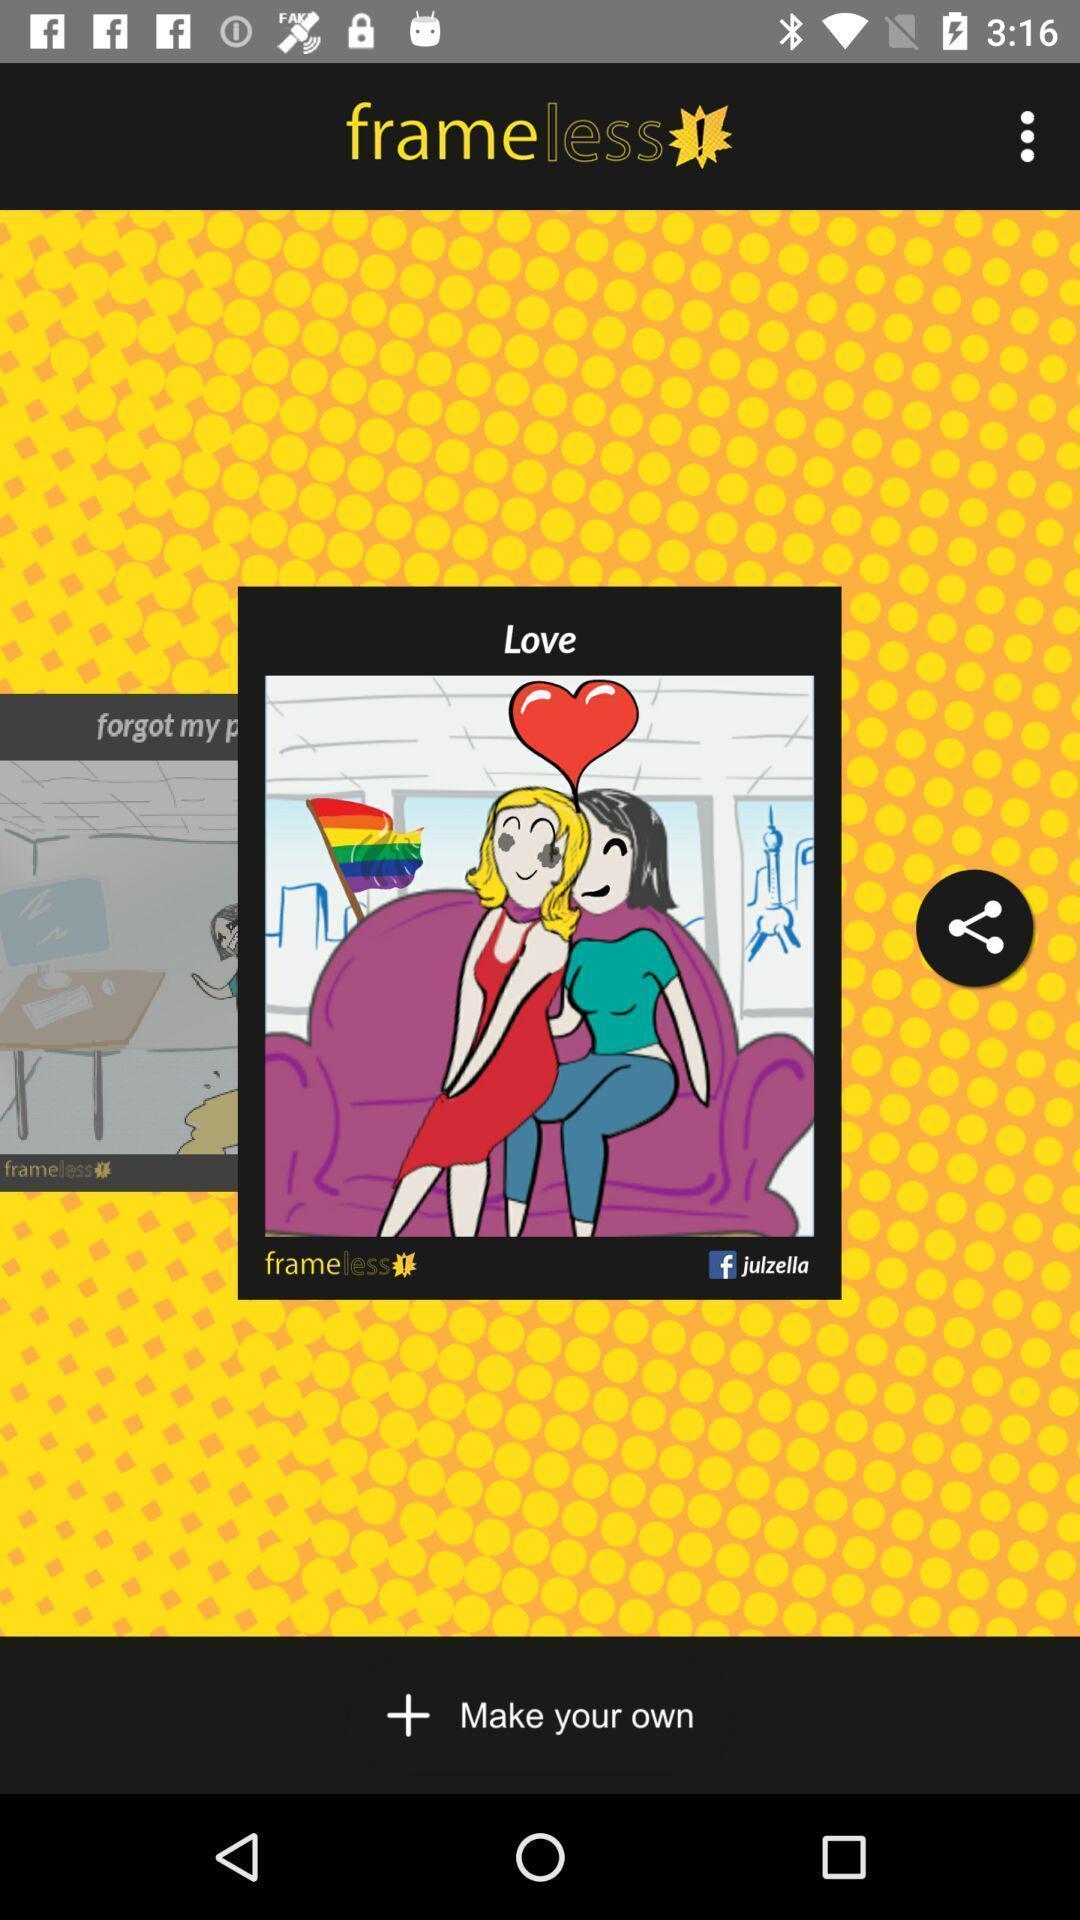Tell me about the visual elements in this screen capture. Page for making own editing and drawings. 